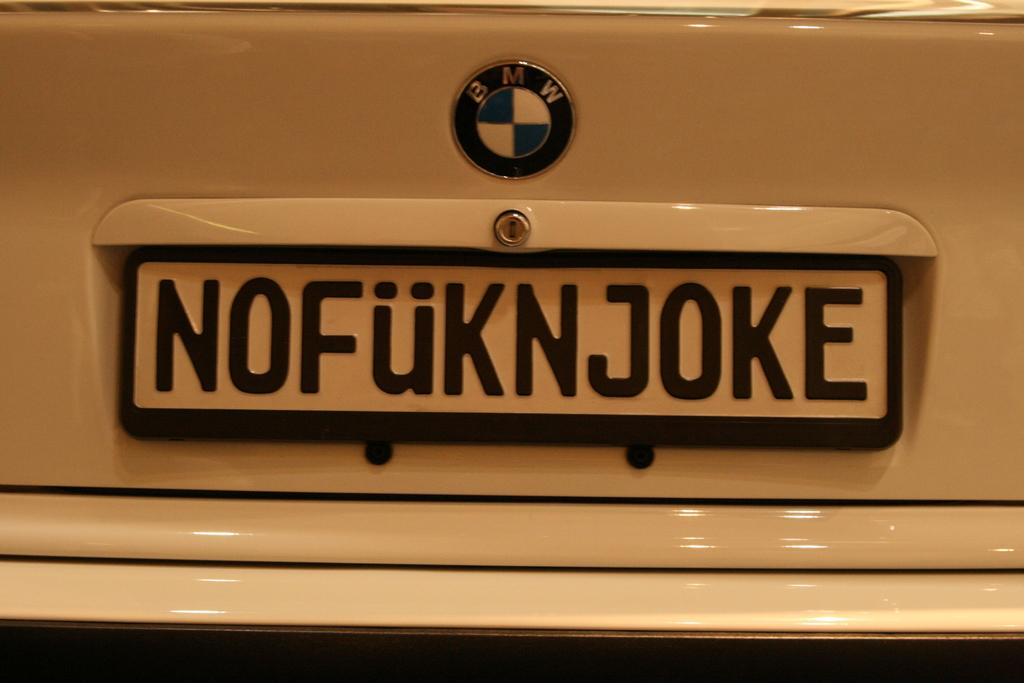<image>
Write a terse but informative summary of the picture. A white BMW has a license plate that says Nofuknjoke. 